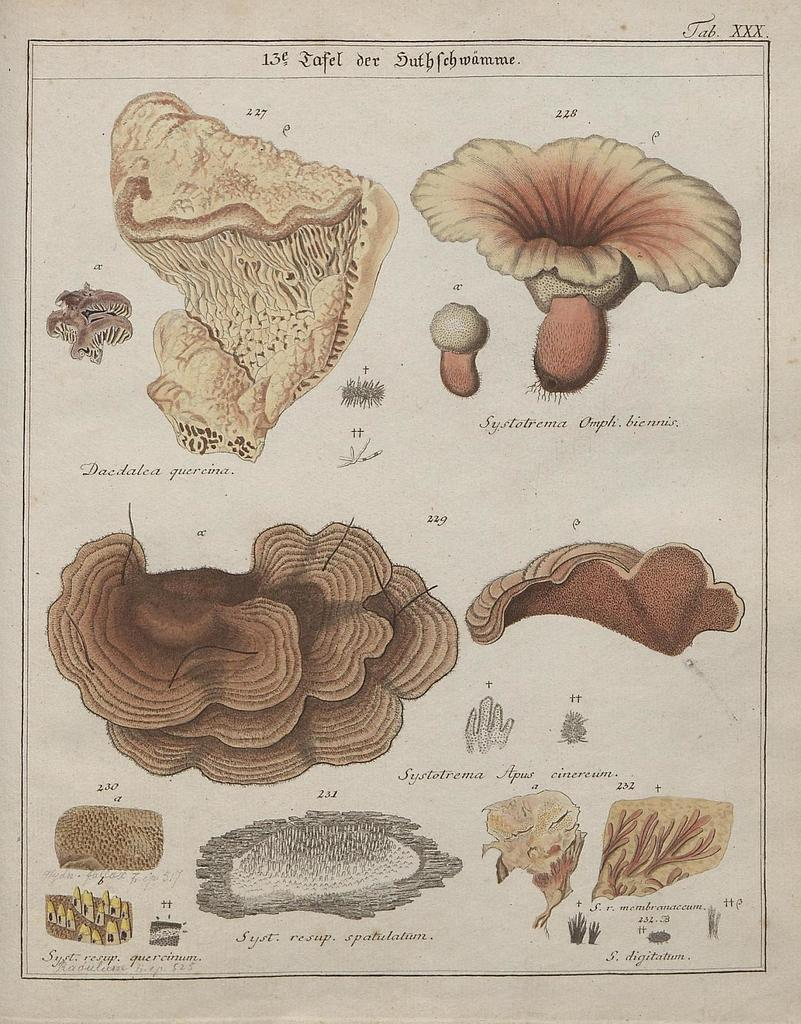What is present in the image related to paper? There is a paper in the image. What can be found on the paper? The paper contains diagrams of flowers. Are there any fangs visible on the flowers in the diagrams? There are no fangs present in the image, as it features diagrams of flowers and not animals with fangs. 